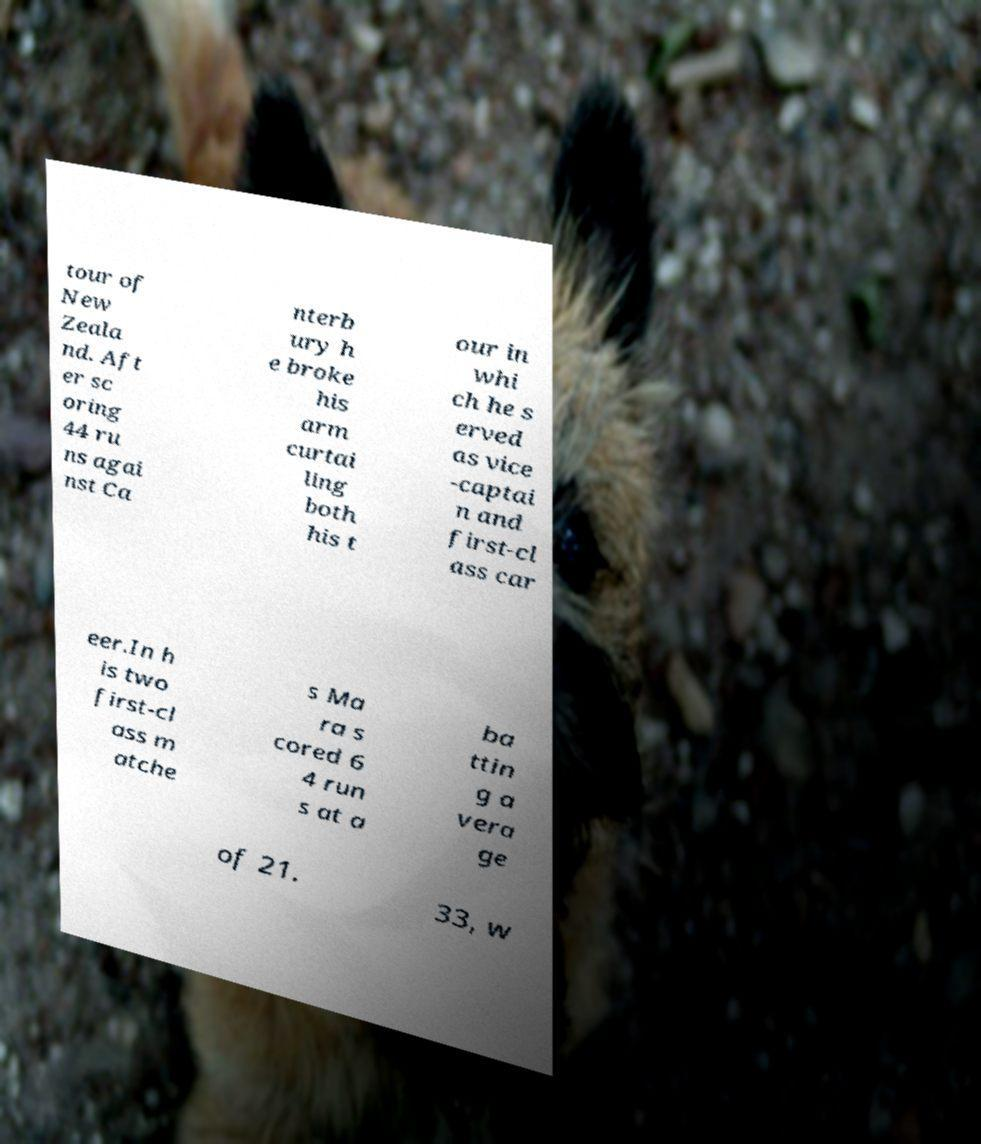Please read and relay the text visible in this image. What does it say? tour of New Zeala nd. Aft er sc oring 44 ru ns agai nst Ca nterb ury h e broke his arm curtai ling both his t our in whi ch he s erved as vice -captai n and first-cl ass car eer.In h is two first-cl ass m atche s Ma ra s cored 6 4 run s at a ba ttin g a vera ge of 21. 33, w 